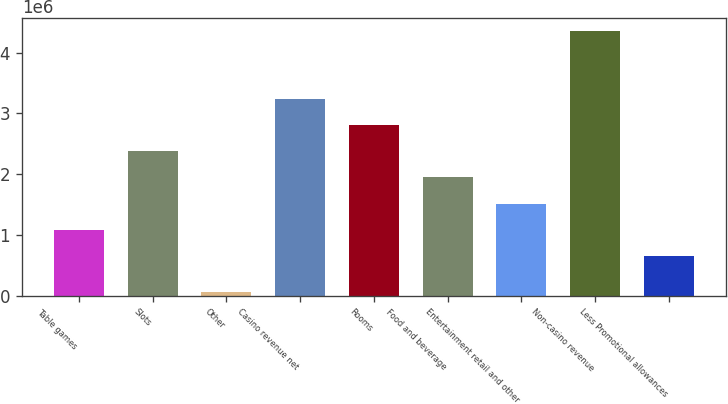Convert chart. <chart><loc_0><loc_0><loc_500><loc_500><bar_chart><fcel>Table games<fcel>Slots<fcel>Other<fcel>Casino revenue net<fcel>Rooms<fcel>Food and beverage<fcel>Entertainment retail and other<fcel>Non-casino revenue<fcel>Less Promotional allowances<nl><fcel>1.08477e+06<fcel>2.37346e+06<fcel>64419<fcel>3.23259e+06<fcel>2.80303e+06<fcel>1.9439e+06<fcel>1.51434e+06<fcel>4.36005e+06<fcel>655211<nl></chart> 